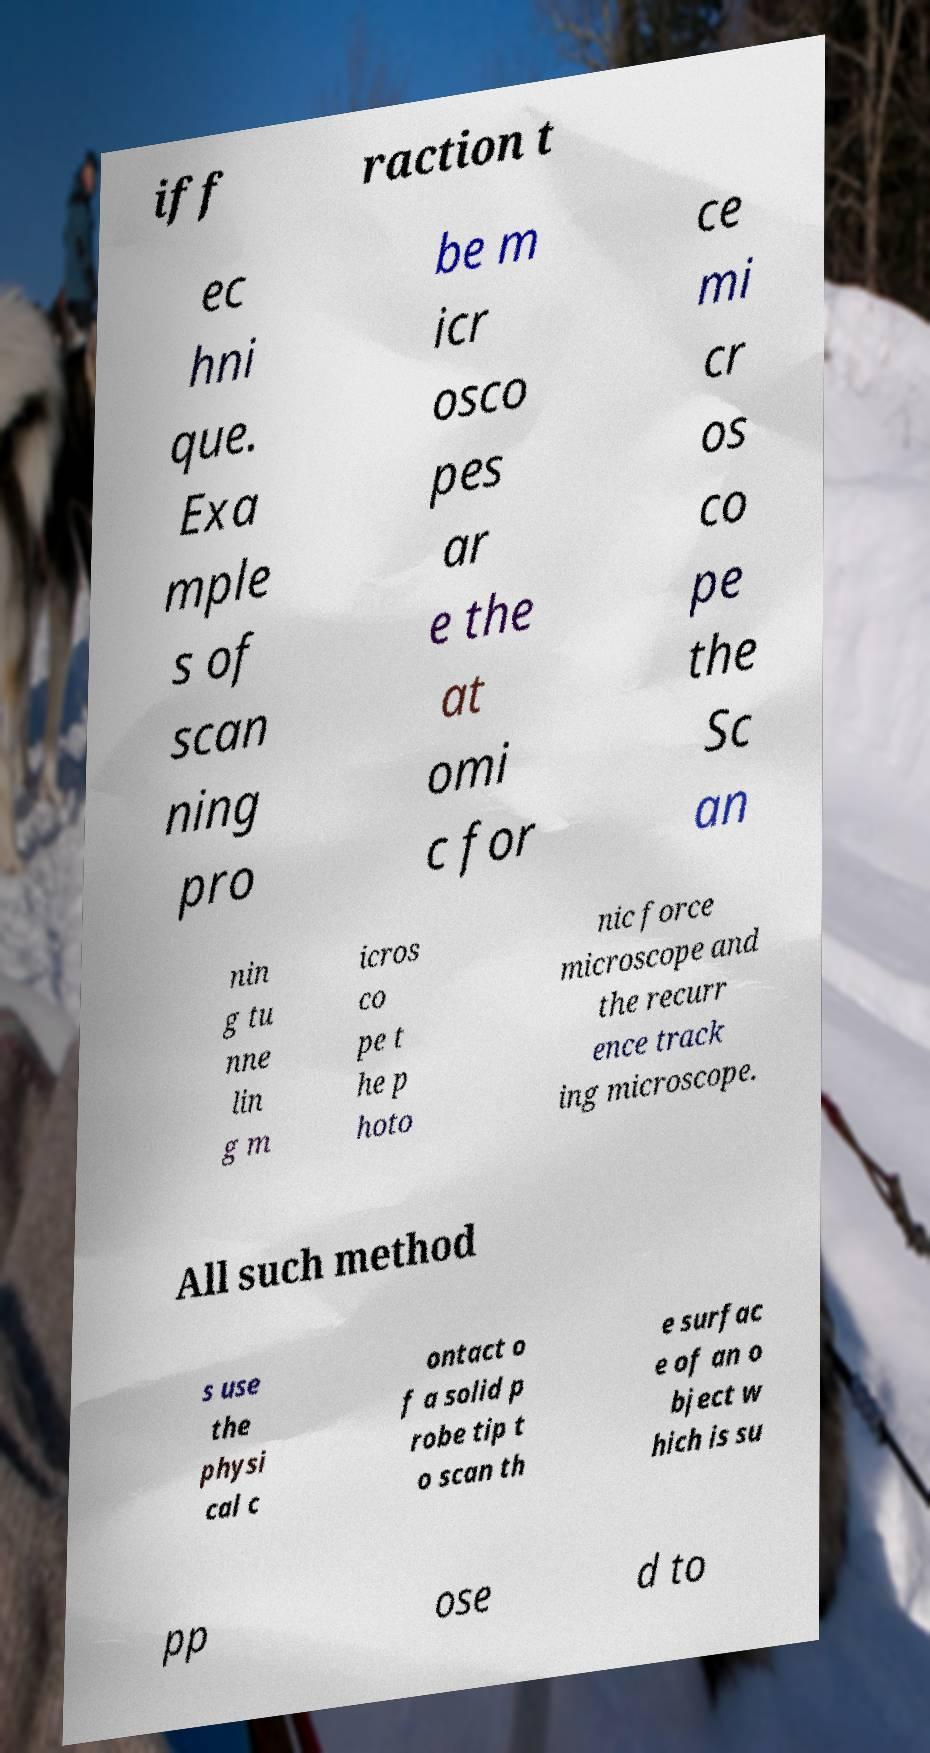Please identify and transcribe the text found in this image. iff raction t ec hni que. Exa mple s of scan ning pro be m icr osco pes ar e the at omi c for ce mi cr os co pe the Sc an nin g tu nne lin g m icros co pe t he p hoto nic force microscope and the recurr ence track ing microscope. All such method s use the physi cal c ontact o f a solid p robe tip t o scan th e surfac e of an o bject w hich is su pp ose d to 